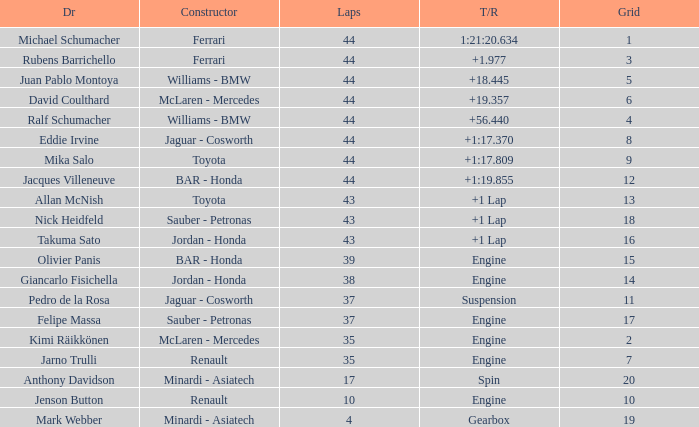What was the retired time on someone who had 43 laps on a grip of 18? +1 Lap. 